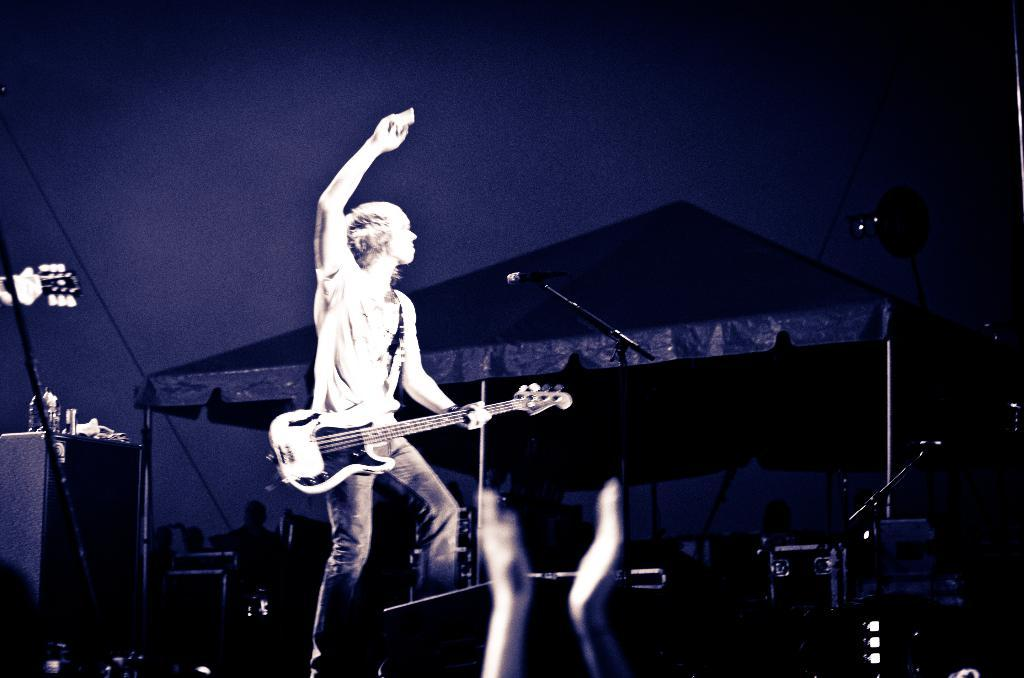What is the person in the image doing? The person is playing a guitar. What object is the person standing in front of? The person is standing in front of a microphone. What can be seen in the background of the image? There is a tent in the background of the image. What type of toothbrush is the person using while playing the guitar? There is no toothbrush present in the image, and the person is not using one while playing the guitar. 